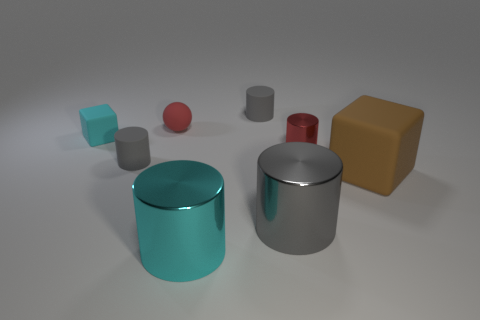Are there more large brown matte cubes that are behind the tiny cyan cube than large metal cylinders?
Make the answer very short. No. Is the big block the same color as the tiny cube?
Ensure brevity in your answer.  No. How many red matte objects have the same shape as the small cyan object?
Give a very brief answer. 0. There is a brown thing that is the same material as the tiny block; what is its size?
Make the answer very short. Large. There is a rubber object that is left of the tiny red matte object and in front of the small metallic cylinder; what color is it?
Ensure brevity in your answer.  Gray. What number of blocks have the same size as the rubber sphere?
Your response must be concise. 1. The metallic object that is the same color as the tiny block is what size?
Give a very brief answer. Large. There is a rubber object that is to the right of the tiny red rubber sphere and to the left of the large brown cube; what size is it?
Provide a succinct answer. Small. There is a small cylinder behind the cyan rubber object that is behind the large brown block; what number of tiny cyan objects are behind it?
Offer a terse response. 0. Is there another small metal cylinder of the same color as the tiny metallic cylinder?
Your response must be concise. No. 